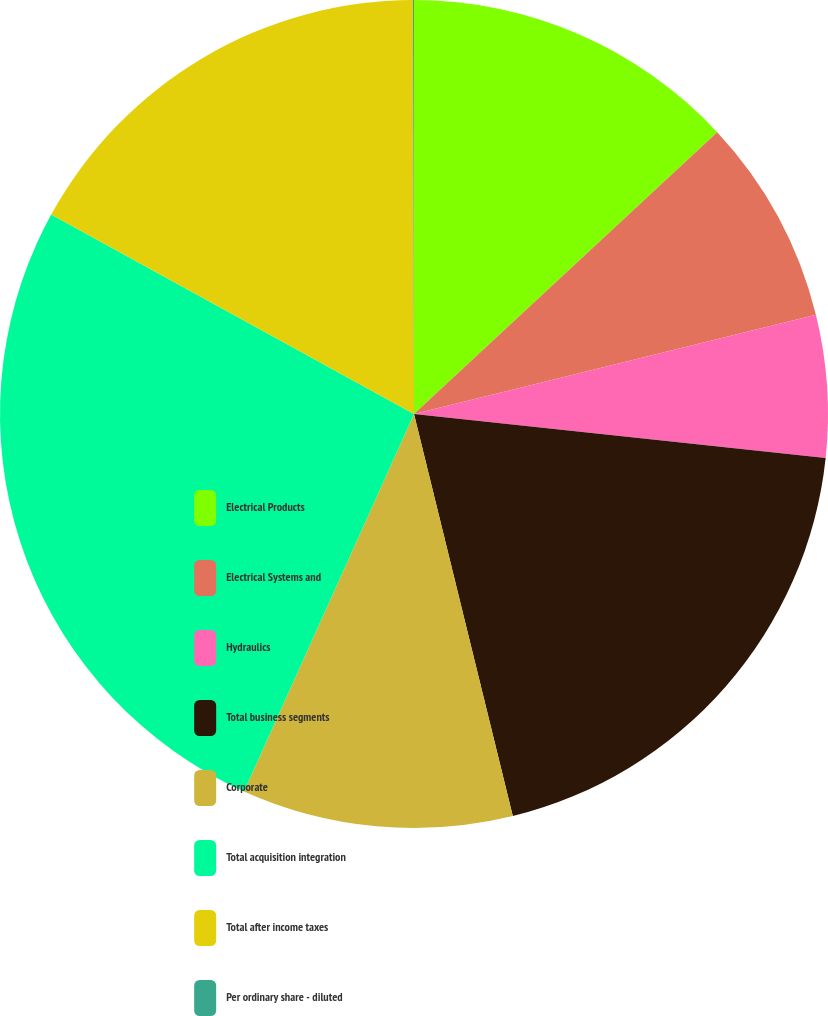Convert chart to OTSL. <chart><loc_0><loc_0><loc_500><loc_500><pie_chart><fcel>Electrical Products<fcel>Electrical Systems and<fcel>Hydraulics<fcel>Total business segments<fcel>Corporate<fcel>Total acquisition integration<fcel>Total after income taxes<fcel>Per ordinary share - diluted<nl><fcel>13.08%<fcel>8.06%<fcel>5.55%<fcel>19.47%<fcel>10.57%<fcel>26.26%<fcel>16.96%<fcel>0.04%<nl></chart> 